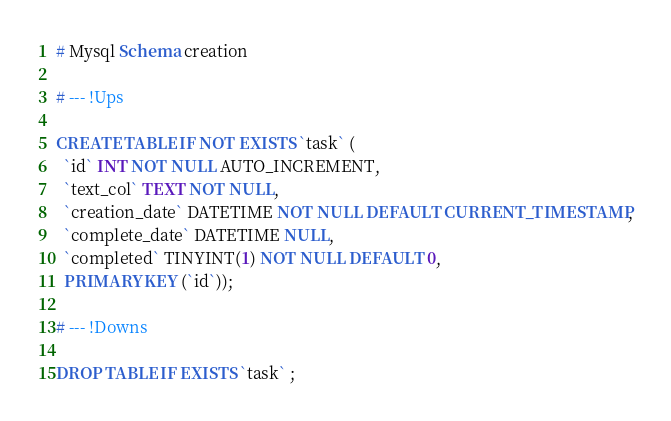<code> <loc_0><loc_0><loc_500><loc_500><_SQL_># Mysql Schema creation

# --- !Ups

CREATE TABLE IF NOT EXISTS `task` (
  `id` INT NOT NULL AUTO_INCREMENT,
  `text_col` TEXT NOT NULL,
  `creation_date` DATETIME NOT NULL DEFAULT CURRENT_TIMESTAMP,
  `complete_date` DATETIME NULL,
  `completed` TINYINT(1) NOT NULL DEFAULT 0,
  PRIMARY KEY (`id`));

# --- !Downs

DROP TABLE IF EXISTS `task` ;</code> 